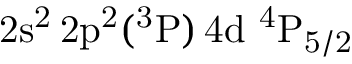<formula> <loc_0><loc_0><loc_500><loc_500>2 s ^ { 2 } \, 2 p ^ { 2 } ( ^ { 3 } P ) \, 4 d ^ { 4 } P _ { 5 / 2 }</formula> 